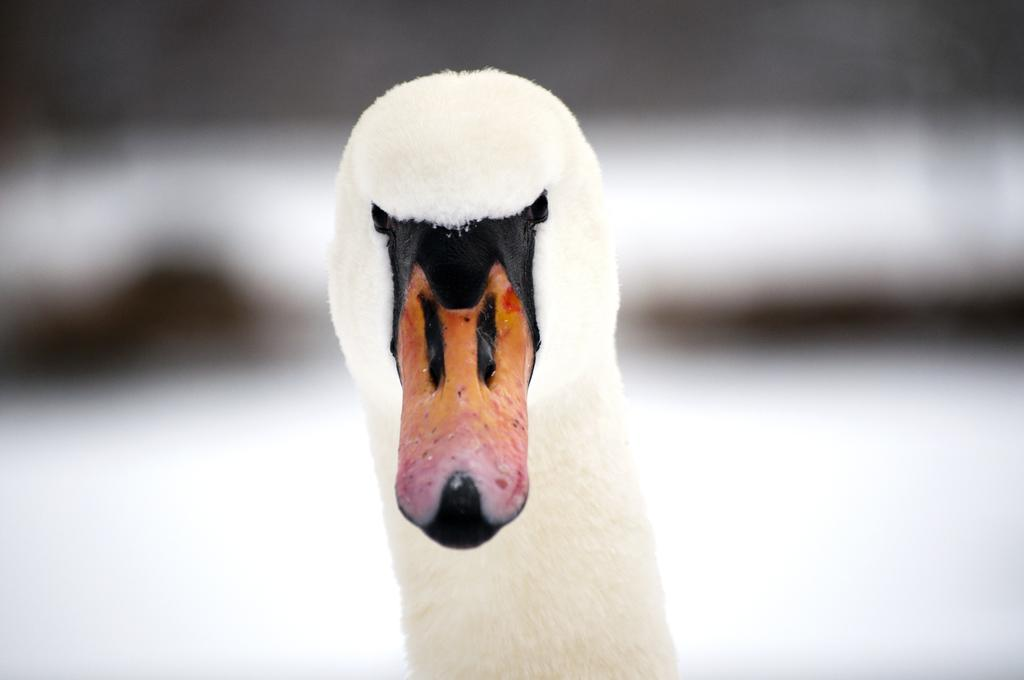What is the main subject in the middle of the image? There is a duck in the middle of the image. Can you describe the background of the image? The background of the image is blurred. What type of cake is being served on the quilt in the image? There is no cake or quilt present in the image; it features a duck with a blurred background. 